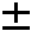<formula> <loc_0><loc_0><loc_500><loc_500>\pm</formula> 